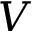Convert formula to latex. <formula><loc_0><loc_0><loc_500><loc_500>V</formula> 